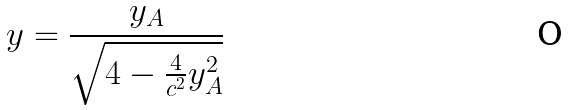Convert formula to latex. <formula><loc_0><loc_0><loc_500><loc_500>y = \frac { y _ { A } } { \sqrt { 4 - \frac { 4 } { c ^ { 2 } } y _ { A } ^ { 2 } } }</formula> 